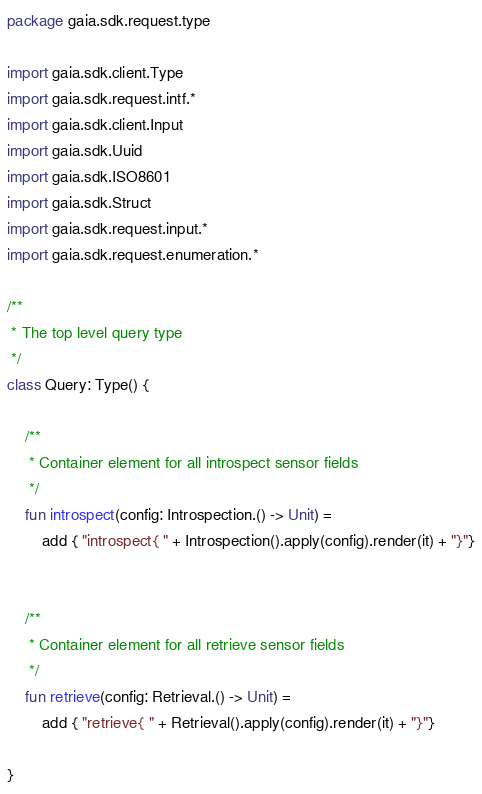Convert code to text. <code><loc_0><loc_0><loc_500><loc_500><_Kotlin_>package gaia.sdk.request.type

import gaia.sdk.client.Type
import gaia.sdk.request.intf.*
import gaia.sdk.client.Input
import gaia.sdk.Uuid
import gaia.sdk.ISO8601
import gaia.sdk.Struct
import gaia.sdk.request.input.*
import gaia.sdk.request.enumeration.*

/**
 * The top level query type
 */
class Query: Type() {

    /**
     * Container element for all introspect sensor fields
     */
    fun introspect(config: Introspection.() -> Unit) = 
        add { "introspect{ " + Introspection().apply(config).render(it) + "}"}


    /**
     * Container element for all retrieve sensor fields
     */
    fun retrieve(config: Retrieval.() -> Unit) = 
        add { "retrieve{ " + Retrieval().apply(config).render(it) + "}"}

}

</code> 